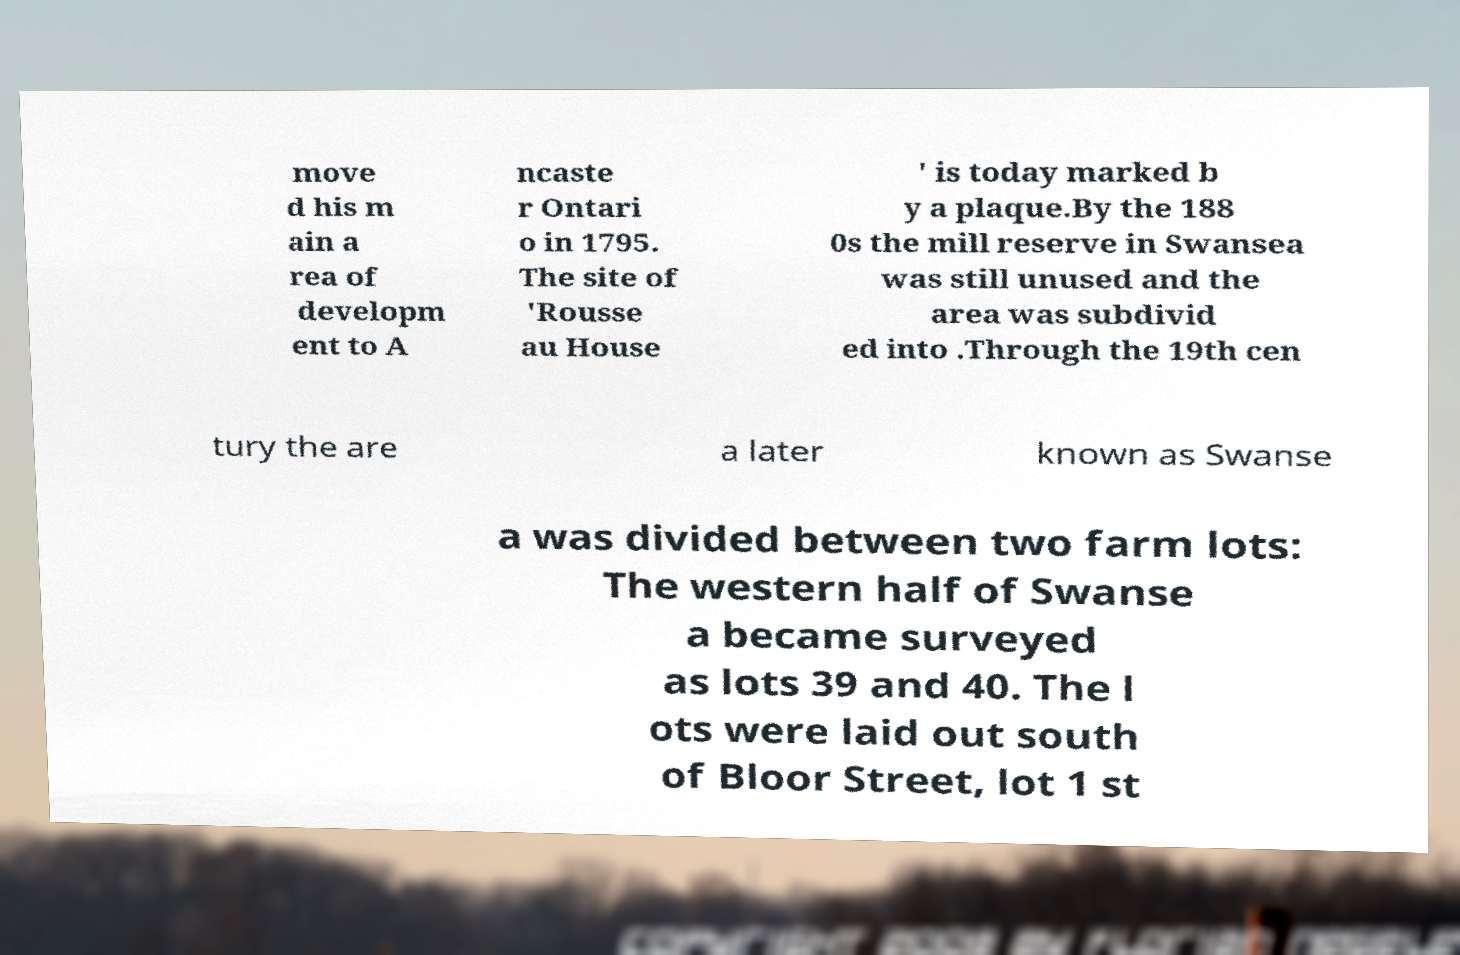For documentation purposes, I need the text within this image transcribed. Could you provide that? move d his m ain a rea of developm ent to A ncaste r Ontari o in 1795. The site of 'Rousse au House ' is today marked b y a plaque.By the 188 0s the mill reserve in Swansea was still unused and the area was subdivid ed into .Through the 19th cen tury the are a later known as Swanse a was divided between two farm lots: The western half of Swanse a became surveyed as lots 39 and 40. The l ots were laid out south of Bloor Street, lot 1 st 